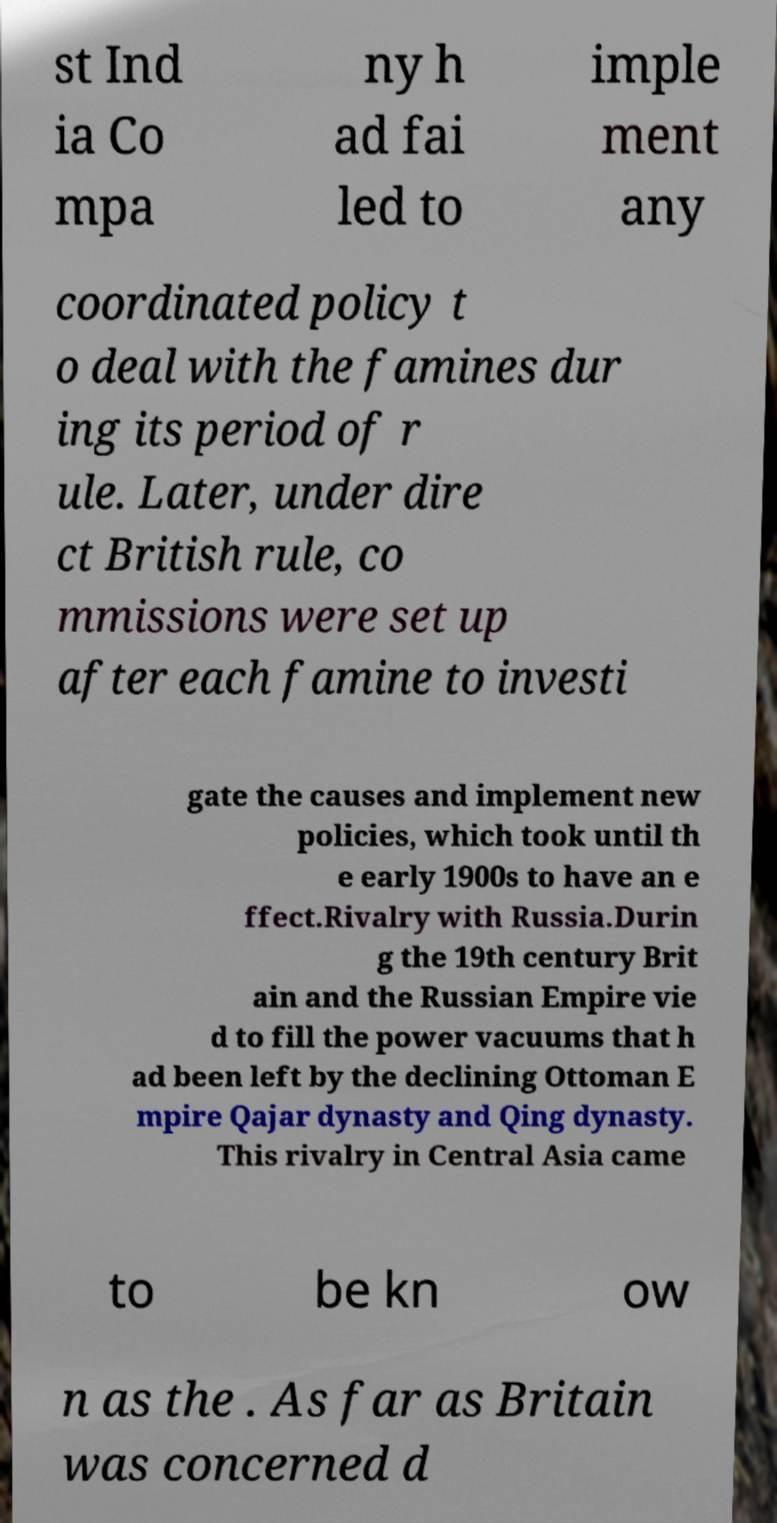Can you read and provide the text displayed in the image?This photo seems to have some interesting text. Can you extract and type it out for me? st Ind ia Co mpa ny h ad fai led to imple ment any coordinated policy t o deal with the famines dur ing its period of r ule. Later, under dire ct British rule, co mmissions were set up after each famine to investi gate the causes and implement new policies, which took until th e early 1900s to have an e ffect.Rivalry with Russia.Durin g the 19th century Brit ain and the Russian Empire vie d to fill the power vacuums that h ad been left by the declining Ottoman E mpire Qajar dynasty and Qing dynasty. This rivalry in Central Asia came to be kn ow n as the . As far as Britain was concerned d 